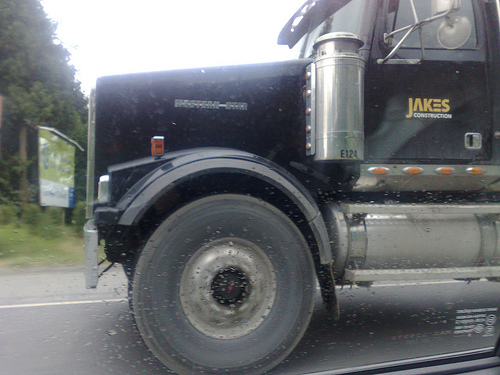<image>
Is the truck above the road? No. The truck is not positioned above the road. The vertical arrangement shows a different relationship. 